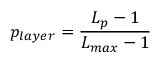Convert formula to latex. <formula><loc_0><loc_0><loc_500><loc_500>p _ { l a y e r } = \frac { L _ { p } - 1 } { L _ { \max } - 1 }</formula> 